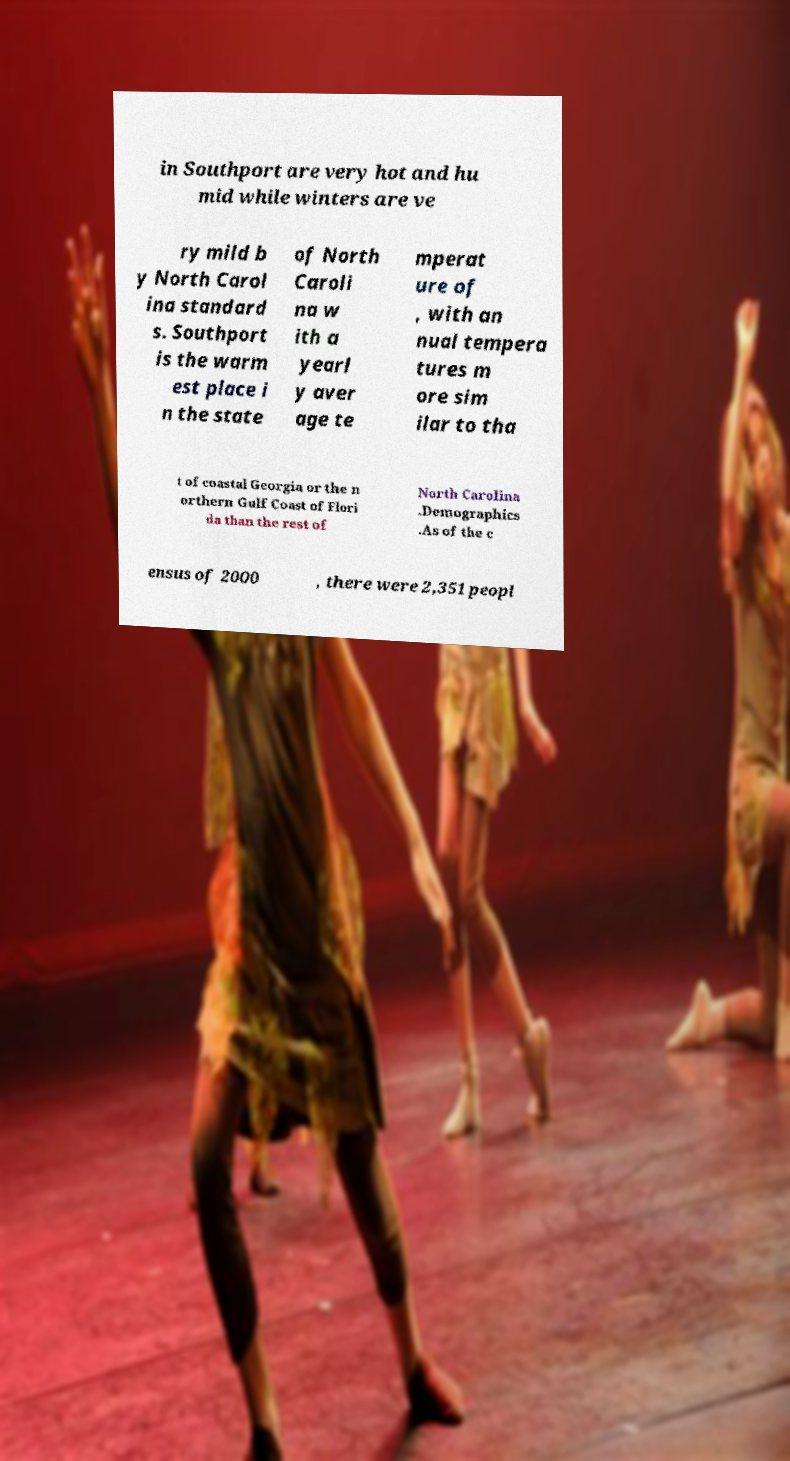For documentation purposes, I need the text within this image transcribed. Could you provide that? in Southport are very hot and hu mid while winters are ve ry mild b y North Carol ina standard s. Southport is the warm est place i n the state of North Caroli na w ith a yearl y aver age te mperat ure of , with an nual tempera tures m ore sim ilar to tha t of coastal Georgia or the n orthern Gulf Coast of Flori da than the rest of North Carolina .Demographics .As of the c ensus of 2000 , there were 2,351 peopl 